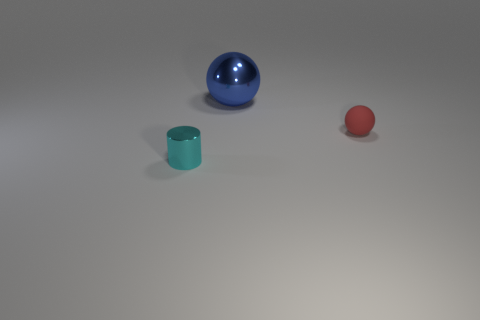How many gray objects are either small metal cubes or large metallic spheres?
Give a very brief answer. 0. Is the number of large spheres that are behind the tiny red sphere greater than the number of tiny blue shiny things?
Provide a short and direct response. Yes. Do the cyan cylinder and the blue metal thing have the same size?
Your answer should be compact. No. There is a tiny object that is the same material as the big blue object; what color is it?
Provide a short and direct response. Cyan. Are there the same number of large things on the right side of the tiny red rubber object and small red balls that are behind the blue metal ball?
Ensure brevity in your answer.  Yes. What is the shape of the red thing in front of the shiny object behind the tiny cyan shiny object?
Make the answer very short. Sphere. There is a large blue object that is the same shape as the small matte object; what is its material?
Your response must be concise. Metal. What is the color of the thing that is the same size as the shiny cylinder?
Provide a succinct answer. Red. Are there the same number of tiny metallic cylinders behind the cylinder and red matte things?
Your answer should be very brief. No. There is a tiny thing that is on the left side of the ball to the right of the big blue object; what color is it?
Give a very brief answer. Cyan. 